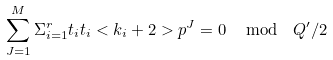<formula> <loc_0><loc_0><loc_500><loc_500>\sum _ { J = 1 } ^ { M } \Sigma _ { i = 1 } ^ { r } t _ { i } t _ { i } < k _ { i } + 2 > p ^ { J } = 0 \, \mod \ Q ^ { \prime } / 2</formula> 